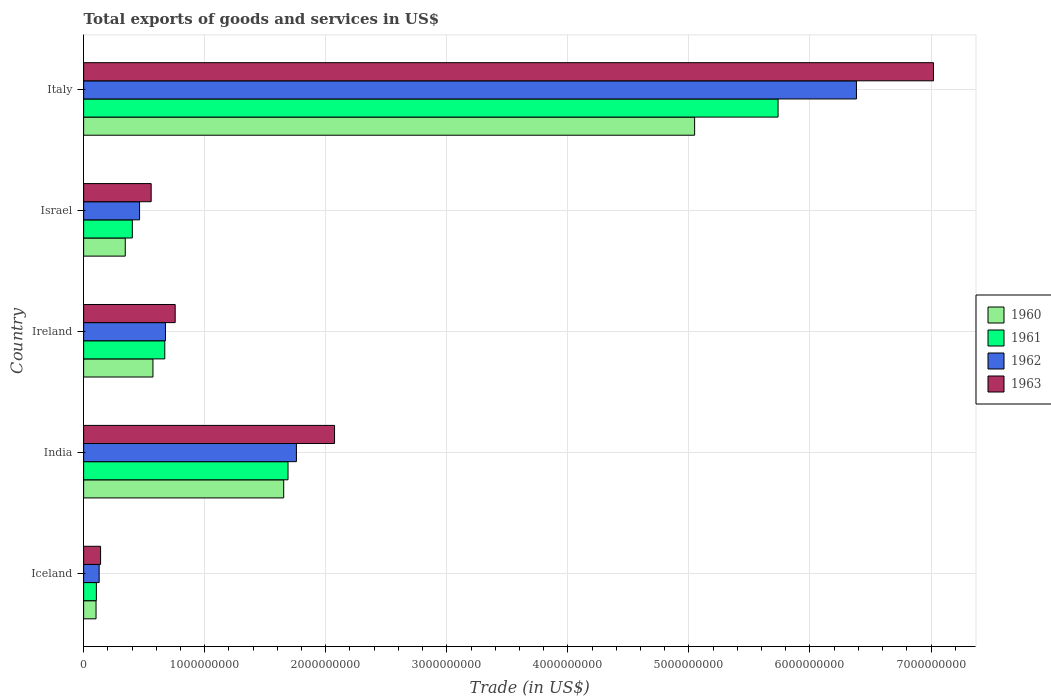How many different coloured bars are there?
Keep it short and to the point. 4. How many groups of bars are there?
Make the answer very short. 5. Are the number of bars on each tick of the Y-axis equal?
Your answer should be compact. Yes. How many bars are there on the 5th tick from the bottom?
Keep it short and to the point. 4. In how many cases, is the number of bars for a given country not equal to the number of legend labels?
Provide a short and direct response. 0. What is the total exports of goods and services in 1963 in Iceland?
Keep it short and to the point. 1.40e+08. Across all countries, what is the maximum total exports of goods and services in 1960?
Ensure brevity in your answer.  5.05e+09. Across all countries, what is the minimum total exports of goods and services in 1963?
Your answer should be compact. 1.40e+08. In which country was the total exports of goods and services in 1960 maximum?
Keep it short and to the point. Italy. In which country was the total exports of goods and services in 1962 minimum?
Your response must be concise. Iceland. What is the total total exports of goods and services in 1963 in the graph?
Provide a short and direct response. 1.05e+1. What is the difference between the total exports of goods and services in 1963 in Iceland and that in Israel?
Give a very brief answer. -4.18e+08. What is the difference between the total exports of goods and services in 1961 in Italy and the total exports of goods and services in 1963 in Iceland?
Your answer should be compact. 5.60e+09. What is the average total exports of goods and services in 1961 per country?
Ensure brevity in your answer.  1.72e+09. What is the difference between the total exports of goods and services in 1960 and total exports of goods and services in 1961 in India?
Your answer should be compact. -3.57e+07. What is the ratio of the total exports of goods and services in 1962 in India to that in Ireland?
Make the answer very short. 2.6. What is the difference between the highest and the second highest total exports of goods and services in 1962?
Provide a succinct answer. 4.63e+09. What is the difference between the highest and the lowest total exports of goods and services in 1961?
Keep it short and to the point. 5.63e+09. What does the 3rd bar from the top in Iceland represents?
Provide a succinct answer. 1961. What does the 4th bar from the bottom in India represents?
Give a very brief answer. 1963. Is it the case that in every country, the sum of the total exports of goods and services in 1962 and total exports of goods and services in 1960 is greater than the total exports of goods and services in 1961?
Your response must be concise. Yes. Are all the bars in the graph horizontal?
Offer a very short reply. Yes. Are the values on the major ticks of X-axis written in scientific E-notation?
Keep it short and to the point. No. Does the graph contain grids?
Your answer should be very brief. Yes. Where does the legend appear in the graph?
Your response must be concise. Center right. How many legend labels are there?
Make the answer very short. 4. How are the legend labels stacked?
Provide a short and direct response. Vertical. What is the title of the graph?
Your response must be concise. Total exports of goods and services in US$. Does "1979" appear as one of the legend labels in the graph?
Keep it short and to the point. No. What is the label or title of the X-axis?
Offer a terse response. Trade (in US$). What is the Trade (in US$) of 1960 in Iceland?
Your answer should be very brief. 1.03e+08. What is the Trade (in US$) of 1961 in Iceland?
Keep it short and to the point. 1.05e+08. What is the Trade (in US$) in 1962 in Iceland?
Give a very brief answer. 1.28e+08. What is the Trade (in US$) of 1963 in Iceland?
Make the answer very short. 1.40e+08. What is the Trade (in US$) of 1960 in India?
Your answer should be very brief. 1.65e+09. What is the Trade (in US$) in 1961 in India?
Your response must be concise. 1.69e+09. What is the Trade (in US$) in 1962 in India?
Give a very brief answer. 1.76e+09. What is the Trade (in US$) of 1963 in India?
Your answer should be compact. 2.07e+09. What is the Trade (in US$) in 1960 in Ireland?
Provide a succinct answer. 5.73e+08. What is the Trade (in US$) of 1961 in Ireland?
Provide a short and direct response. 6.70e+08. What is the Trade (in US$) of 1962 in Ireland?
Provide a succinct answer. 6.76e+08. What is the Trade (in US$) of 1963 in Ireland?
Your response must be concise. 7.56e+08. What is the Trade (in US$) in 1960 in Israel?
Your response must be concise. 3.44e+08. What is the Trade (in US$) of 1961 in Israel?
Offer a terse response. 4.02e+08. What is the Trade (in US$) in 1962 in Israel?
Make the answer very short. 4.62e+08. What is the Trade (in US$) in 1963 in Israel?
Your answer should be very brief. 5.58e+08. What is the Trade (in US$) in 1960 in Italy?
Offer a very short reply. 5.05e+09. What is the Trade (in US$) of 1961 in Italy?
Provide a short and direct response. 5.74e+09. What is the Trade (in US$) of 1962 in Italy?
Provide a succinct answer. 6.38e+09. What is the Trade (in US$) in 1963 in Italy?
Keep it short and to the point. 7.02e+09. Across all countries, what is the maximum Trade (in US$) in 1960?
Ensure brevity in your answer.  5.05e+09. Across all countries, what is the maximum Trade (in US$) of 1961?
Your answer should be very brief. 5.74e+09. Across all countries, what is the maximum Trade (in US$) in 1962?
Provide a short and direct response. 6.38e+09. Across all countries, what is the maximum Trade (in US$) in 1963?
Your answer should be very brief. 7.02e+09. Across all countries, what is the minimum Trade (in US$) of 1960?
Provide a short and direct response. 1.03e+08. Across all countries, what is the minimum Trade (in US$) in 1961?
Offer a terse response. 1.05e+08. Across all countries, what is the minimum Trade (in US$) in 1962?
Your answer should be very brief. 1.28e+08. Across all countries, what is the minimum Trade (in US$) in 1963?
Your answer should be compact. 1.40e+08. What is the total Trade (in US$) of 1960 in the graph?
Ensure brevity in your answer.  7.72e+09. What is the total Trade (in US$) of 1961 in the graph?
Provide a succinct answer. 8.60e+09. What is the total Trade (in US$) in 1962 in the graph?
Offer a terse response. 9.41e+09. What is the total Trade (in US$) of 1963 in the graph?
Offer a very short reply. 1.05e+1. What is the difference between the Trade (in US$) of 1960 in Iceland and that in India?
Offer a very short reply. -1.55e+09. What is the difference between the Trade (in US$) in 1961 in Iceland and that in India?
Ensure brevity in your answer.  -1.58e+09. What is the difference between the Trade (in US$) in 1962 in Iceland and that in India?
Provide a short and direct response. -1.63e+09. What is the difference between the Trade (in US$) in 1963 in Iceland and that in India?
Give a very brief answer. -1.93e+09. What is the difference between the Trade (in US$) in 1960 in Iceland and that in Ireland?
Your answer should be compact. -4.70e+08. What is the difference between the Trade (in US$) in 1961 in Iceland and that in Ireland?
Your response must be concise. -5.65e+08. What is the difference between the Trade (in US$) of 1962 in Iceland and that in Ireland?
Your answer should be compact. -5.48e+08. What is the difference between the Trade (in US$) in 1963 in Iceland and that in Ireland?
Offer a very short reply. -6.16e+08. What is the difference between the Trade (in US$) of 1960 in Iceland and that in Israel?
Ensure brevity in your answer.  -2.41e+08. What is the difference between the Trade (in US$) of 1961 in Iceland and that in Israel?
Your answer should be compact. -2.97e+08. What is the difference between the Trade (in US$) in 1962 in Iceland and that in Israel?
Offer a terse response. -3.34e+08. What is the difference between the Trade (in US$) of 1963 in Iceland and that in Israel?
Your answer should be compact. -4.18e+08. What is the difference between the Trade (in US$) of 1960 in Iceland and that in Italy?
Ensure brevity in your answer.  -4.94e+09. What is the difference between the Trade (in US$) of 1961 in Iceland and that in Italy?
Provide a short and direct response. -5.63e+09. What is the difference between the Trade (in US$) of 1962 in Iceland and that in Italy?
Offer a terse response. -6.26e+09. What is the difference between the Trade (in US$) of 1963 in Iceland and that in Italy?
Make the answer very short. -6.88e+09. What is the difference between the Trade (in US$) of 1960 in India and that in Ireland?
Offer a very short reply. 1.08e+09. What is the difference between the Trade (in US$) in 1961 in India and that in Ireland?
Make the answer very short. 1.02e+09. What is the difference between the Trade (in US$) in 1962 in India and that in Ireland?
Offer a terse response. 1.08e+09. What is the difference between the Trade (in US$) in 1963 in India and that in Ireland?
Your answer should be very brief. 1.32e+09. What is the difference between the Trade (in US$) in 1960 in India and that in Israel?
Your response must be concise. 1.31e+09. What is the difference between the Trade (in US$) in 1961 in India and that in Israel?
Your answer should be compact. 1.29e+09. What is the difference between the Trade (in US$) of 1962 in India and that in Israel?
Offer a very short reply. 1.30e+09. What is the difference between the Trade (in US$) of 1963 in India and that in Israel?
Provide a short and direct response. 1.51e+09. What is the difference between the Trade (in US$) in 1960 in India and that in Italy?
Your answer should be very brief. -3.39e+09. What is the difference between the Trade (in US$) in 1961 in India and that in Italy?
Give a very brief answer. -4.05e+09. What is the difference between the Trade (in US$) of 1962 in India and that in Italy?
Your response must be concise. -4.63e+09. What is the difference between the Trade (in US$) in 1963 in India and that in Italy?
Offer a terse response. -4.95e+09. What is the difference between the Trade (in US$) in 1960 in Ireland and that in Israel?
Offer a very short reply. 2.29e+08. What is the difference between the Trade (in US$) of 1961 in Ireland and that in Israel?
Make the answer very short. 2.68e+08. What is the difference between the Trade (in US$) in 1962 in Ireland and that in Israel?
Your answer should be compact. 2.14e+08. What is the difference between the Trade (in US$) of 1963 in Ireland and that in Israel?
Your answer should be compact. 1.98e+08. What is the difference between the Trade (in US$) of 1960 in Ireland and that in Italy?
Provide a short and direct response. -4.47e+09. What is the difference between the Trade (in US$) of 1961 in Ireland and that in Italy?
Offer a very short reply. -5.07e+09. What is the difference between the Trade (in US$) in 1962 in Ireland and that in Italy?
Offer a very short reply. -5.71e+09. What is the difference between the Trade (in US$) of 1963 in Ireland and that in Italy?
Provide a short and direct response. -6.26e+09. What is the difference between the Trade (in US$) in 1960 in Israel and that in Italy?
Give a very brief answer. -4.70e+09. What is the difference between the Trade (in US$) of 1961 in Israel and that in Italy?
Provide a succinct answer. -5.33e+09. What is the difference between the Trade (in US$) of 1962 in Israel and that in Italy?
Offer a terse response. -5.92e+09. What is the difference between the Trade (in US$) in 1963 in Israel and that in Italy?
Offer a very short reply. -6.46e+09. What is the difference between the Trade (in US$) in 1960 in Iceland and the Trade (in US$) in 1961 in India?
Make the answer very short. -1.59e+09. What is the difference between the Trade (in US$) in 1960 in Iceland and the Trade (in US$) in 1962 in India?
Provide a succinct answer. -1.66e+09. What is the difference between the Trade (in US$) in 1960 in Iceland and the Trade (in US$) in 1963 in India?
Offer a very short reply. -1.97e+09. What is the difference between the Trade (in US$) of 1961 in Iceland and the Trade (in US$) of 1962 in India?
Keep it short and to the point. -1.65e+09. What is the difference between the Trade (in US$) of 1961 in Iceland and the Trade (in US$) of 1963 in India?
Make the answer very short. -1.97e+09. What is the difference between the Trade (in US$) of 1962 in Iceland and the Trade (in US$) of 1963 in India?
Your response must be concise. -1.94e+09. What is the difference between the Trade (in US$) of 1960 in Iceland and the Trade (in US$) of 1961 in Ireland?
Ensure brevity in your answer.  -5.68e+08. What is the difference between the Trade (in US$) in 1960 in Iceland and the Trade (in US$) in 1962 in Ireland?
Give a very brief answer. -5.73e+08. What is the difference between the Trade (in US$) of 1960 in Iceland and the Trade (in US$) of 1963 in Ireland?
Make the answer very short. -6.54e+08. What is the difference between the Trade (in US$) of 1961 in Iceland and the Trade (in US$) of 1962 in Ireland?
Your response must be concise. -5.71e+08. What is the difference between the Trade (in US$) of 1961 in Iceland and the Trade (in US$) of 1963 in Ireland?
Provide a succinct answer. -6.51e+08. What is the difference between the Trade (in US$) in 1962 in Iceland and the Trade (in US$) in 1963 in Ireland?
Give a very brief answer. -6.28e+08. What is the difference between the Trade (in US$) in 1960 in Iceland and the Trade (in US$) in 1961 in Israel?
Offer a very short reply. -3.00e+08. What is the difference between the Trade (in US$) in 1960 in Iceland and the Trade (in US$) in 1962 in Israel?
Give a very brief answer. -3.60e+08. What is the difference between the Trade (in US$) of 1960 in Iceland and the Trade (in US$) of 1963 in Israel?
Offer a very short reply. -4.55e+08. What is the difference between the Trade (in US$) of 1961 in Iceland and the Trade (in US$) of 1962 in Israel?
Provide a succinct answer. -3.57e+08. What is the difference between the Trade (in US$) in 1961 in Iceland and the Trade (in US$) in 1963 in Israel?
Your response must be concise. -4.53e+08. What is the difference between the Trade (in US$) of 1962 in Iceland and the Trade (in US$) of 1963 in Israel?
Your answer should be compact. -4.30e+08. What is the difference between the Trade (in US$) in 1960 in Iceland and the Trade (in US$) in 1961 in Italy?
Keep it short and to the point. -5.63e+09. What is the difference between the Trade (in US$) in 1960 in Iceland and the Trade (in US$) in 1962 in Italy?
Make the answer very short. -6.28e+09. What is the difference between the Trade (in US$) of 1960 in Iceland and the Trade (in US$) of 1963 in Italy?
Your answer should be compact. -6.92e+09. What is the difference between the Trade (in US$) of 1961 in Iceland and the Trade (in US$) of 1962 in Italy?
Your answer should be very brief. -6.28e+09. What is the difference between the Trade (in US$) of 1961 in Iceland and the Trade (in US$) of 1963 in Italy?
Offer a terse response. -6.92e+09. What is the difference between the Trade (in US$) of 1962 in Iceland and the Trade (in US$) of 1963 in Italy?
Your answer should be compact. -6.89e+09. What is the difference between the Trade (in US$) of 1960 in India and the Trade (in US$) of 1961 in Ireland?
Provide a succinct answer. 9.82e+08. What is the difference between the Trade (in US$) of 1960 in India and the Trade (in US$) of 1962 in Ireland?
Your answer should be compact. 9.77e+08. What is the difference between the Trade (in US$) of 1960 in India and the Trade (in US$) of 1963 in Ireland?
Your response must be concise. 8.96e+08. What is the difference between the Trade (in US$) in 1961 in India and the Trade (in US$) in 1962 in Ireland?
Give a very brief answer. 1.01e+09. What is the difference between the Trade (in US$) of 1961 in India and the Trade (in US$) of 1963 in Ireland?
Your answer should be very brief. 9.32e+08. What is the difference between the Trade (in US$) in 1962 in India and the Trade (in US$) in 1963 in Ireland?
Your response must be concise. 1.00e+09. What is the difference between the Trade (in US$) of 1960 in India and the Trade (in US$) of 1961 in Israel?
Offer a very short reply. 1.25e+09. What is the difference between the Trade (in US$) in 1960 in India and the Trade (in US$) in 1962 in Israel?
Give a very brief answer. 1.19e+09. What is the difference between the Trade (in US$) of 1960 in India and the Trade (in US$) of 1963 in Israel?
Offer a very short reply. 1.09e+09. What is the difference between the Trade (in US$) of 1961 in India and the Trade (in US$) of 1962 in Israel?
Give a very brief answer. 1.23e+09. What is the difference between the Trade (in US$) in 1961 in India and the Trade (in US$) in 1963 in Israel?
Offer a terse response. 1.13e+09. What is the difference between the Trade (in US$) in 1962 in India and the Trade (in US$) in 1963 in Israel?
Your response must be concise. 1.20e+09. What is the difference between the Trade (in US$) of 1960 in India and the Trade (in US$) of 1961 in Italy?
Give a very brief answer. -4.08e+09. What is the difference between the Trade (in US$) in 1960 in India and the Trade (in US$) in 1962 in Italy?
Your answer should be very brief. -4.73e+09. What is the difference between the Trade (in US$) in 1960 in India and the Trade (in US$) in 1963 in Italy?
Make the answer very short. -5.37e+09. What is the difference between the Trade (in US$) in 1961 in India and the Trade (in US$) in 1962 in Italy?
Keep it short and to the point. -4.70e+09. What is the difference between the Trade (in US$) in 1961 in India and the Trade (in US$) in 1963 in Italy?
Your answer should be very brief. -5.33e+09. What is the difference between the Trade (in US$) of 1962 in India and the Trade (in US$) of 1963 in Italy?
Provide a short and direct response. -5.26e+09. What is the difference between the Trade (in US$) of 1960 in Ireland and the Trade (in US$) of 1961 in Israel?
Your answer should be very brief. 1.70e+08. What is the difference between the Trade (in US$) in 1960 in Ireland and the Trade (in US$) in 1962 in Israel?
Offer a terse response. 1.11e+08. What is the difference between the Trade (in US$) of 1960 in Ireland and the Trade (in US$) of 1963 in Israel?
Offer a very short reply. 1.46e+07. What is the difference between the Trade (in US$) of 1961 in Ireland and the Trade (in US$) of 1962 in Israel?
Provide a short and direct response. 2.08e+08. What is the difference between the Trade (in US$) of 1961 in Ireland and the Trade (in US$) of 1963 in Israel?
Give a very brief answer. 1.12e+08. What is the difference between the Trade (in US$) in 1962 in Ireland and the Trade (in US$) in 1963 in Israel?
Make the answer very short. 1.18e+08. What is the difference between the Trade (in US$) of 1960 in Ireland and the Trade (in US$) of 1961 in Italy?
Ensure brevity in your answer.  -5.16e+09. What is the difference between the Trade (in US$) of 1960 in Ireland and the Trade (in US$) of 1962 in Italy?
Give a very brief answer. -5.81e+09. What is the difference between the Trade (in US$) in 1960 in Ireland and the Trade (in US$) in 1963 in Italy?
Make the answer very short. -6.45e+09. What is the difference between the Trade (in US$) in 1961 in Ireland and the Trade (in US$) in 1962 in Italy?
Your answer should be very brief. -5.71e+09. What is the difference between the Trade (in US$) of 1961 in Ireland and the Trade (in US$) of 1963 in Italy?
Your answer should be very brief. -6.35e+09. What is the difference between the Trade (in US$) in 1962 in Ireland and the Trade (in US$) in 1963 in Italy?
Make the answer very short. -6.34e+09. What is the difference between the Trade (in US$) of 1960 in Israel and the Trade (in US$) of 1961 in Italy?
Your response must be concise. -5.39e+09. What is the difference between the Trade (in US$) in 1960 in Israel and the Trade (in US$) in 1962 in Italy?
Give a very brief answer. -6.04e+09. What is the difference between the Trade (in US$) of 1960 in Israel and the Trade (in US$) of 1963 in Italy?
Provide a short and direct response. -6.68e+09. What is the difference between the Trade (in US$) of 1961 in Israel and the Trade (in US$) of 1962 in Italy?
Offer a very short reply. -5.98e+09. What is the difference between the Trade (in US$) of 1961 in Israel and the Trade (in US$) of 1963 in Italy?
Give a very brief answer. -6.62e+09. What is the difference between the Trade (in US$) in 1962 in Israel and the Trade (in US$) in 1963 in Italy?
Your answer should be very brief. -6.56e+09. What is the average Trade (in US$) in 1960 per country?
Keep it short and to the point. 1.54e+09. What is the average Trade (in US$) in 1961 per country?
Offer a terse response. 1.72e+09. What is the average Trade (in US$) in 1962 per country?
Offer a terse response. 1.88e+09. What is the average Trade (in US$) in 1963 per country?
Your response must be concise. 2.11e+09. What is the difference between the Trade (in US$) in 1960 and Trade (in US$) in 1961 in Iceland?
Offer a very short reply. -2.55e+06. What is the difference between the Trade (in US$) of 1960 and Trade (in US$) of 1962 in Iceland?
Offer a terse response. -2.58e+07. What is the difference between the Trade (in US$) in 1960 and Trade (in US$) in 1963 in Iceland?
Ensure brevity in your answer.  -3.74e+07. What is the difference between the Trade (in US$) of 1961 and Trade (in US$) of 1962 in Iceland?
Offer a terse response. -2.32e+07. What is the difference between the Trade (in US$) of 1961 and Trade (in US$) of 1963 in Iceland?
Make the answer very short. -3.49e+07. What is the difference between the Trade (in US$) in 1962 and Trade (in US$) in 1963 in Iceland?
Provide a short and direct response. -1.17e+07. What is the difference between the Trade (in US$) in 1960 and Trade (in US$) in 1961 in India?
Your answer should be very brief. -3.57e+07. What is the difference between the Trade (in US$) of 1960 and Trade (in US$) of 1962 in India?
Keep it short and to the point. -1.05e+08. What is the difference between the Trade (in US$) of 1960 and Trade (in US$) of 1963 in India?
Provide a succinct answer. -4.20e+08. What is the difference between the Trade (in US$) in 1961 and Trade (in US$) in 1962 in India?
Your answer should be very brief. -6.93e+07. What is the difference between the Trade (in US$) in 1961 and Trade (in US$) in 1963 in India?
Offer a terse response. -3.84e+08. What is the difference between the Trade (in US$) of 1962 and Trade (in US$) of 1963 in India?
Ensure brevity in your answer.  -3.15e+08. What is the difference between the Trade (in US$) of 1960 and Trade (in US$) of 1961 in Ireland?
Provide a succinct answer. -9.77e+07. What is the difference between the Trade (in US$) of 1960 and Trade (in US$) of 1962 in Ireland?
Your response must be concise. -1.03e+08. What is the difference between the Trade (in US$) of 1960 and Trade (in US$) of 1963 in Ireland?
Offer a very short reply. -1.84e+08. What is the difference between the Trade (in US$) of 1961 and Trade (in US$) of 1962 in Ireland?
Ensure brevity in your answer.  -5.70e+06. What is the difference between the Trade (in US$) of 1961 and Trade (in US$) of 1963 in Ireland?
Offer a very short reply. -8.60e+07. What is the difference between the Trade (in US$) of 1962 and Trade (in US$) of 1963 in Ireland?
Your response must be concise. -8.03e+07. What is the difference between the Trade (in US$) of 1960 and Trade (in US$) of 1961 in Israel?
Offer a terse response. -5.83e+07. What is the difference between the Trade (in US$) in 1960 and Trade (in US$) in 1962 in Israel?
Keep it short and to the point. -1.18e+08. What is the difference between the Trade (in US$) in 1960 and Trade (in US$) in 1963 in Israel?
Give a very brief answer. -2.14e+08. What is the difference between the Trade (in US$) of 1961 and Trade (in US$) of 1962 in Israel?
Your answer should be compact. -5.98e+07. What is the difference between the Trade (in US$) of 1961 and Trade (in US$) of 1963 in Israel?
Provide a succinct answer. -1.56e+08. What is the difference between the Trade (in US$) in 1962 and Trade (in US$) in 1963 in Israel?
Your response must be concise. -9.59e+07. What is the difference between the Trade (in US$) of 1960 and Trade (in US$) of 1961 in Italy?
Ensure brevity in your answer.  -6.89e+08. What is the difference between the Trade (in US$) of 1960 and Trade (in US$) of 1962 in Italy?
Provide a short and direct response. -1.34e+09. What is the difference between the Trade (in US$) of 1960 and Trade (in US$) of 1963 in Italy?
Provide a succinct answer. -1.97e+09. What is the difference between the Trade (in US$) of 1961 and Trade (in US$) of 1962 in Italy?
Your answer should be very brief. -6.47e+08. What is the difference between the Trade (in US$) of 1961 and Trade (in US$) of 1963 in Italy?
Offer a very short reply. -1.28e+09. What is the difference between the Trade (in US$) in 1962 and Trade (in US$) in 1963 in Italy?
Your answer should be compact. -6.37e+08. What is the ratio of the Trade (in US$) in 1960 in Iceland to that in India?
Your response must be concise. 0.06. What is the ratio of the Trade (in US$) of 1961 in Iceland to that in India?
Your response must be concise. 0.06. What is the ratio of the Trade (in US$) of 1962 in Iceland to that in India?
Your response must be concise. 0.07. What is the ratio of the Trade (in US$) in 1963 in Iceland to that in India?
Your answer should be compact. 0.07. What is the ratio of the Trade (in US$) of 1960 in Iceland to that in Ireland?
Offer a terse response. 0.18. What is the ratio of the Trade (in US$) of 1961 in Iceland to that in Ireland?
Keep it short and to the point. 0.16. What is the ratio of the Trade (in US$) in 1962 in Iceland to that in Ireland?
Keep it short and to the point. 0.19. What is the ratio of the Trade (in US$) of 1963 in Iceland to that in Ireland?
Your answer should be compact. 0.19. What is the ratio of the Trade (in US$) in 1960 in Iceland to that in Israel?
Your response must be concise. 0.3. What is the ratio of the Trade (in US$) of 1961 in Iceland to that in Israel?
Keep it short and to the point. 0.26. What is the ratio of the Trade (in US$) of 1962 in Iceland to that in Israel?
Provide a short and direct response. 0.28. What is the ratio of the Trade (in US$) in 1963 in Iceland to that in Israel?
Give a very brief answer. 0.25. What is the ratio of the Trade (in US$) of 1960 in Iceland to that in Italy?
Your answer should be very brief. 0.02. What is the ratio of the Trade (in US$) in 1961 in Iceland to that in Italy?
Provide a succinct answer. 0.02. What is the ratio of the Trade (in US$) of 1962 in Iceland to that in Italy?
Offer a very short reply. 0.02. What is the ratio of the Trade (in US$) of 1963 in Iceland to that in Italy?
Ensure brevity in your answer.  0.02. What is the ratio of the Trade (in US$) in 1960 in India to that in Ireland?
Keep it short and to the point. 2.89. What is the ratio of the Trade (in US$) of 1961 in India to that in Ireland?
Offer a very short reply. 2.52. What is the ratio of the Trade (in US$) of 1962 in India to that in Ireland?
Make the answer very short. 2.6. What is the ratio of the Trade (in US$) in 1963 in India to that in Ireland?
Provide a succinct answer. 2.74. What is the ratio of the Trade (in US$) in 1960 in India to that in Israel?
Keep it short and to the point. 4.81. What is the ratio of the Trade (in US$) in 1961 in India to that in Israel?
Your response must be concise. 4.2. What is the ratio of the Trade (in US$) of 1962 in India to that in Israel?
Give a very brief answer. 3.8. What is the ratio of the Trade (in US$) in 1963 in India to that in Israel?
Your answer should be very brief. 3.71. What is the ratio of the Trade (in US$) of 1960 in India to that in Italy?
Offer a very short reply. 0.33. What is the ratio of the Trade (in US$) in 1961 in India to that in Italy?
Ensure brevity in your answer.  0.29. What is the ratio of the Trade (in US$) of 1962 in India to that in Italy?
Keep it short and to the point. 0.28. What is the ratio of the Trade (in US$) in 1963 in India to that in Italy?
Your answer should be compact. 0.3. What is the ratio of the Trade (in US$) of 1960 in Ireland to that in Israel?
Offer a terse response. 1.67. What is the ratio of the Trade (in US$) in 1961 in Ireland to that in Israel?
Provide a short and direct response. 1.67. What is the ratio of the Trade (in US$) of 1962 in Ireland to that in Israel?
Your answer should be very brief. 1.46. What is the ratio of the Trade (in US$) of 1963 in Ireland to that in Israel?
Make the answer very short. 1.36. What is the ratio of the Trade (in US$) in 1960 in Ireland to that in Italy?
Keep it short and to the point. 0.11. What is the ratio of the Trade (in US$) in 1961 in Ireland to that in Italy?
Provide a succinct answer. 0.12. What is the ratio of the Trade (in US$) of 1962 in Ireland to that in Italy?
Offer a very short reply. 0.11. What is the ratio of the Trade (in US$) in 1963 in Ireland to that in Italy?
Provide a succinct answer. 0.11. What is the ratio of the Trade (in US$) of 1960 in Israel to that in Italy?
Your response must be concise. 0.07. What is the ratio of the Trade (in US$) of 1961 in Israel to that in Italy?
Your answer should be very brief. 0.07. What is the ratio of the Trade (in US$) of 1962 in Israel to that in Italy?
Your response must be concise. 0.07. What is the ratio of the Trade (in US$) of 1963 in Israel to that in Italy?
Your answer should be compact. 0.08. What is the difference between the highest and the second highest Trade (in US$) in 1960?
Give a very brief answer. 3.39e+09. What is the difference between the highest and the second highest Trade (in US$) in 1961?
Make the answer very short. 4.05e+09. What is the difference between the highest and the second highest Trade (in US$) in 1962?
Provide a short and direct response. 4.63e+09. What is the difference between the highest and the second highest Trade (in US$) in 1963?
Give a very brief answer. 4.95e+09. What is the difference between the highest and the lowest Trade (in US$) in 1960?
Make the answer very short. 4.94e+09. What is the difference between the highest and the lowest Trade (in US$) in 1961?
Ensure brevity in your answer.  5.63e+09. What is the difference between the highest and the lowest Trade (in US$) of 1962?
Provide a short and direct response. 6.26e+09. What is the difference between the highest and the lowest Trade (in US$) in 1963?
Your answer should be very brief. 6.88e+09. 